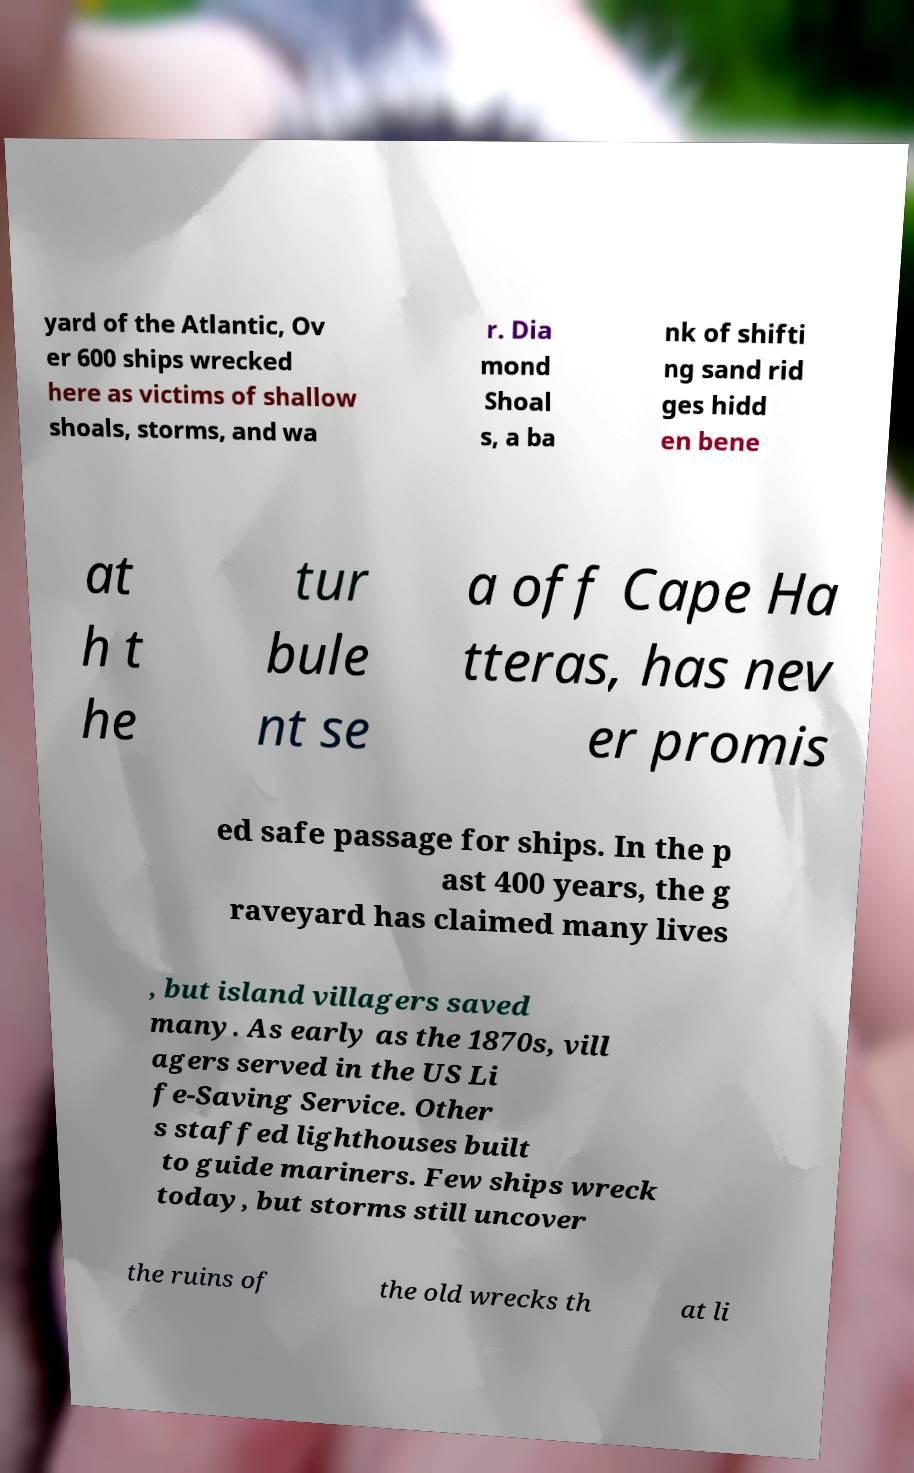What messages or text are displayed in this image? I need them in a readable, typed format. yard of the Atlantic, Ov er 600 ships wrecked here as victims of shallow shoals, storms, and wa r. Dia mond Shoal s, a ba nk of shifti ng sand rid ges hidd en bene at h t he tur bule nt se a off Cape Ha tteras, has nev er promis ed safe passage for ships. In the p ast 400 years, the g raveyard has claimed many lives , but island villagers saved many. As early as the 1870s, vill agers served in the US Li fe-Saving Service. Other s staffed lighthouses built to guide mariners. Few ships wreck today, but storms still uncover the ruins of the old wrecks th at li 